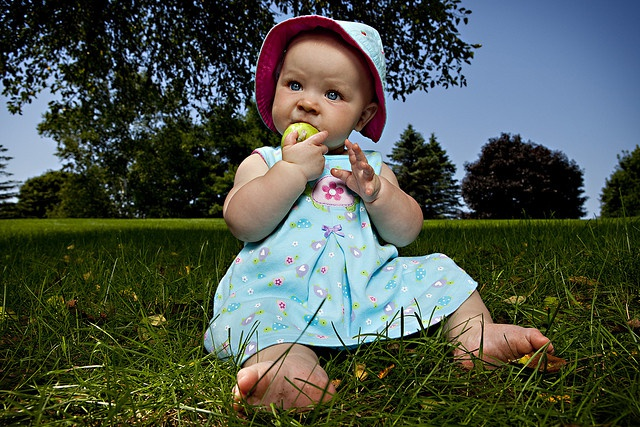Describe the objects in this image and their specific colors. I can see people in black, lightblue, tan, and gray tones and apple in black, khaki, olive, and ivory tones in this image. 